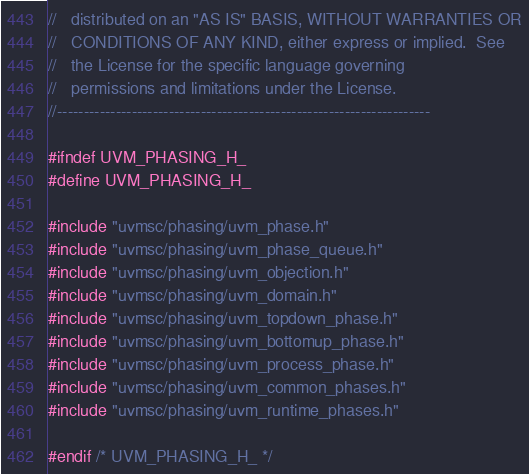<code> <loc_0><loc_0><loc_500><loc_500><_C_>//   distributed on an "AS IS" BASIS, WITHOUT WARRANTIES OR
//   CONDITIONS OF ANY KIND, either express or implied.  See
//   the License for the specific language governing
//   permissions and limitations under the License.
//----------------------------------------------------------------------

#ifndef UVM_PHASING_H_
#define UVM_PHASING_H_

#include "uvmsc/phasing/uvm_phase.h"
#include "uvmsc/phasing/uvm_phase_queue.h"
#include "uvmsc/phasing/uvm_objection.h"
#include "uvmsc/phasing/uvm_domain.h"
#include "uvmsc/phasing/uvm_topdown_phase.h"
#include "uvmsc/phasing/uvm_bottomup_phase.h"
#include "uvmsc/phasing/uvm_process_phase.h"
#include "uvmsc/phasing/uvm_common_phases.h"
#include "uvmsc/phasing/uvm_runtime_phases.h"

#endif /* UVM_PHASING_H_ */
</code> 